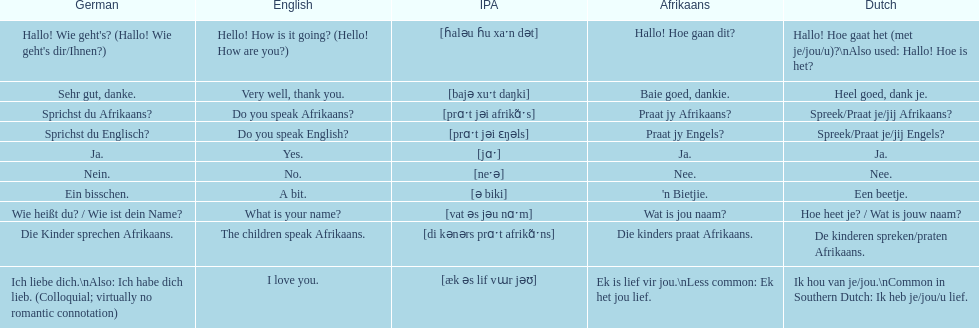How do you say "do you speak afrikaans?" in afrikaans? Praat jy Afrikaans?. 